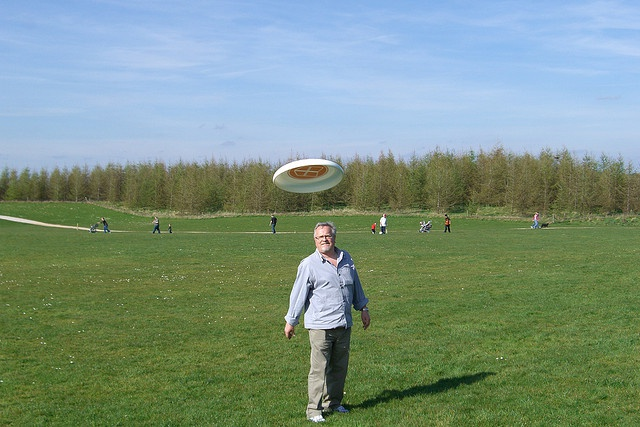Describe the objects in this image and their specific colors. I can see people in lightblue, lavender, black, darkgray, and gray tones, frisbee in lightblue, white, and gray tones, people in lightblue, gray, brown, and darkgray tones, people in lightblue, black, gray, darkgreen, and olive tones, and people in lightblue, white, black, navy, and gray tones in this image. 